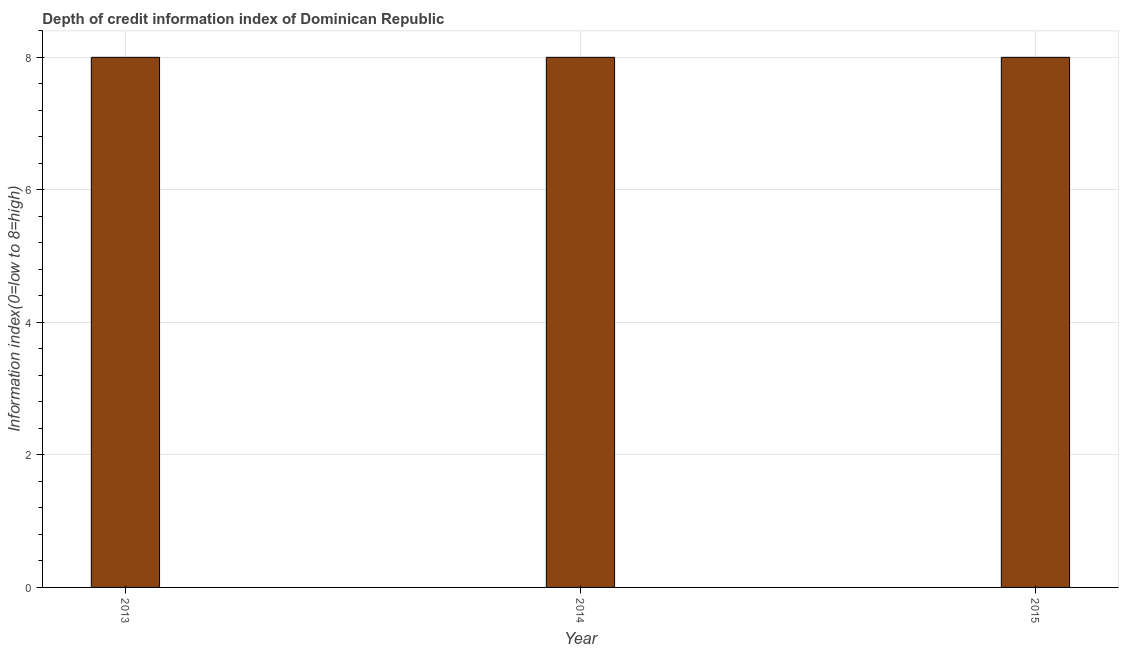Does the graph contain any zero values?
Give a very brief answer. No. Does the graph contain grids?
Keep it short and to the point. Yes. What is the title of the graph?
Offer a very short reply. Depth of credit information index of Dominican Republic. What is the label or title of the Y-axis?
Provide a short and direct response. Information index(0=low to 8=high). In which year was the depth of credit information index maximum?
Make the answer very short. 2013. In which year was the depth of credit information index minimum?
Give a very brief answer. 2013. What is the difference between the depth of credit information index in 2014 and 2015?
Keep it short and to the point. 0. What is the median depth of credit information index?
Keep it short and to the point. 8. What is the ratio of the depth of credit information index in 2013 to that in 2014?
Your answer should be very brief. 1. Is the depth of credit information index in 2013 less than that in 2014?
Give a very brief answer. No. Is the sum of the depth of credit information index in 2013 and 2015 greater than the maximum depth of credit information index across all years?
Ensure brevity in your answer.  Yes. What is the difference between the highest and the lowest depth of credit information index?
Your response must be concise. 0. In how many years, is the depth of credit information index greater than the average depth of credit information index taken over all years?
Ensure brevity in your answer.  0. How many years are there in the graph?
Provide a short and direct response. 3. What is the difference between two consecutive major ticks on the Y-axis?
Offer a very short reply. 2. What is the Information index(0=low to 8=high) of 2015?
Your answer should be compact. 8. What is the difference between the Information index(0=low to 8=high) in 2013 and 2014?
Make the answer very short. 0. What is the difference between the Information index(0=low to 8=high) in 2013 and 2015?
Offer a very short reply. 0. 